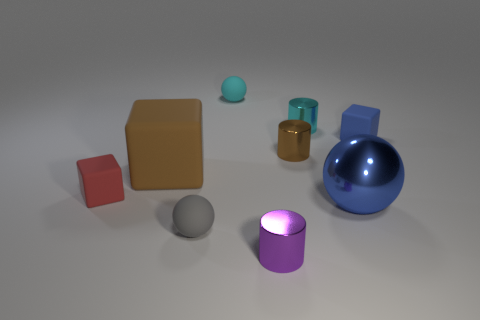Subtract all small balls. How many balls are left? 1 Add 1 red balls. How many objects exist? 10 Subtract 1 red cubes. How many objects are left? 8 Subtract all tiny gray things. Subtract all tiny cyan rubber objects. How many objects are left? 7 Add 5 balls. How many balls are left? 8 Add 4 big gray blocks. How many big gray blocks exist? 4 